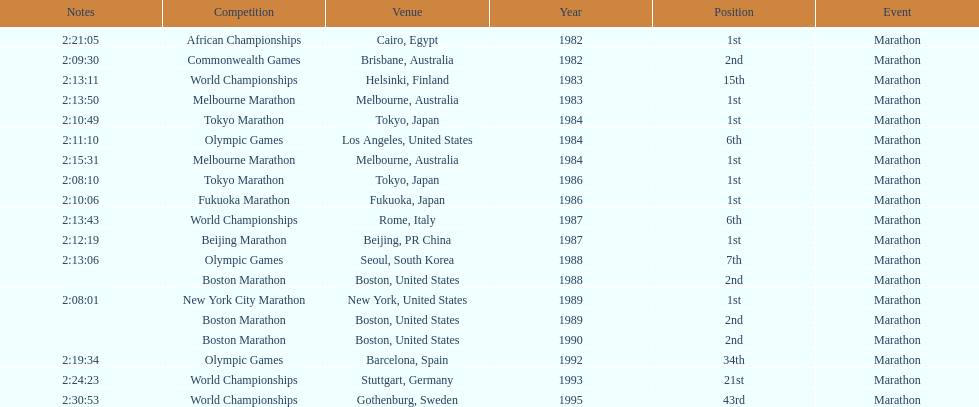In the olympic games, how many marathon events did ikangaa compete in? 3. 